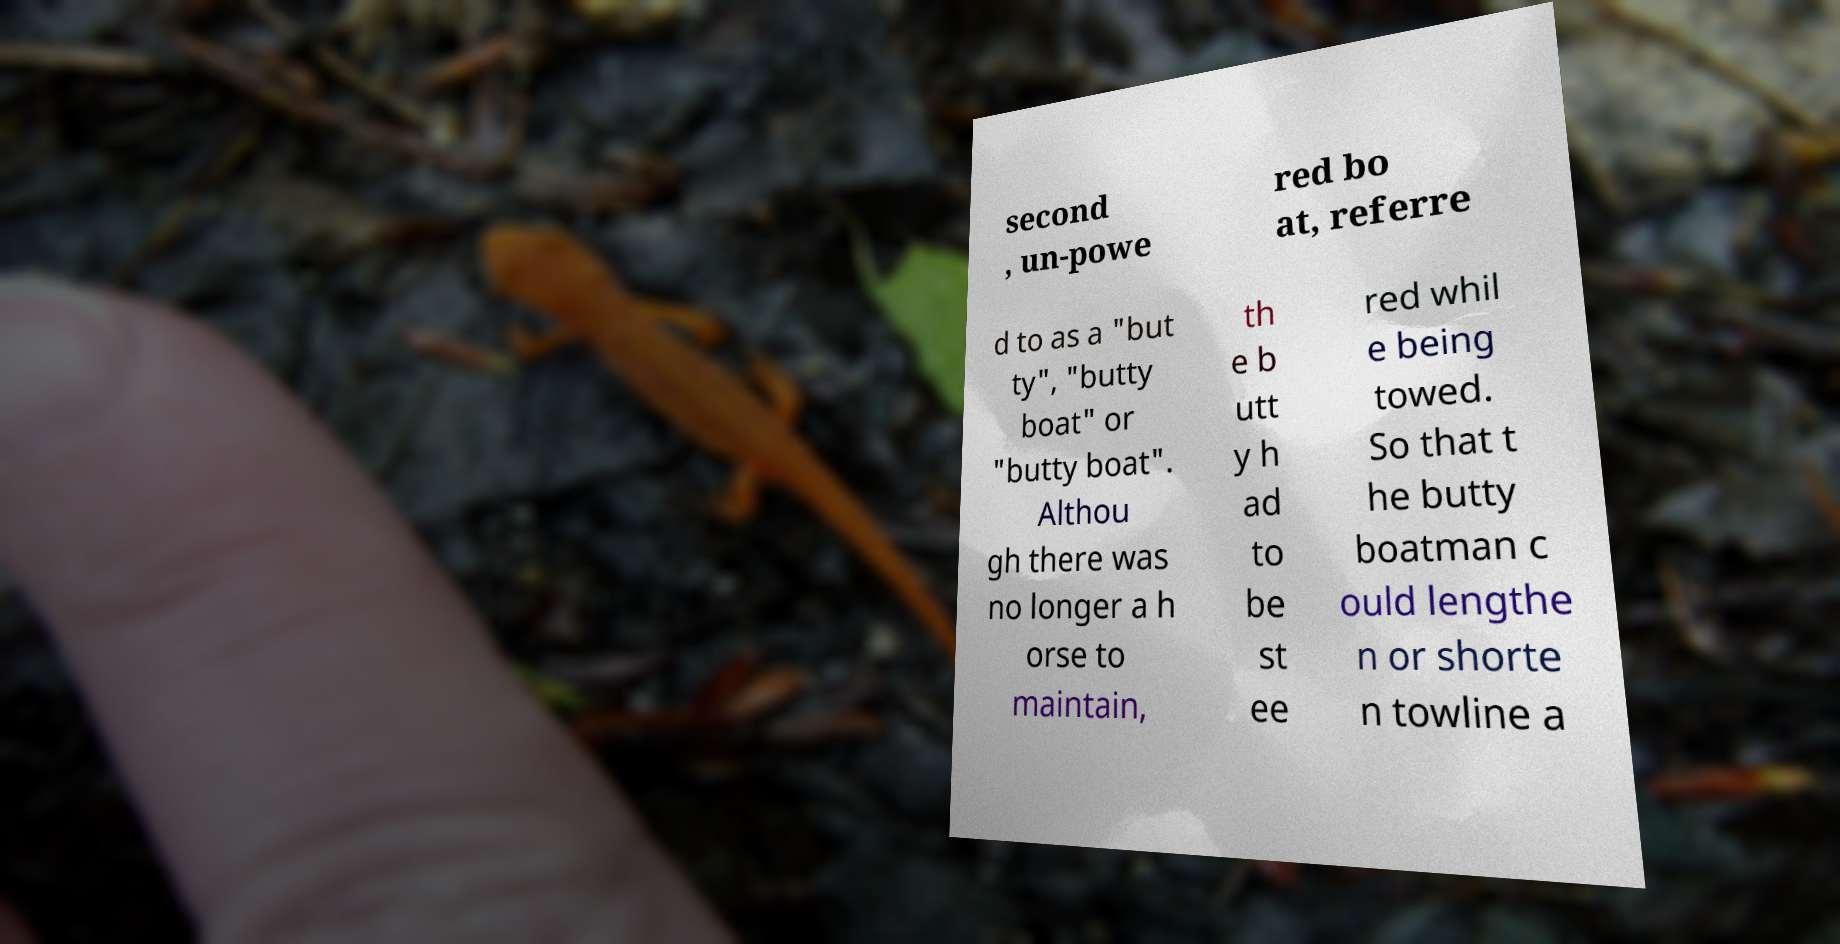Could you extract and type out the text from this image? second , un-powe red bo at, referre d to as a "but ty", "butty boat" or "butty boat". Althou gh there was no longer a h orse to maintain, th e b utt y h ad to be st ee red whil e being towed. So that t he butty boatman c ould lengthe n or shorte n towline a 